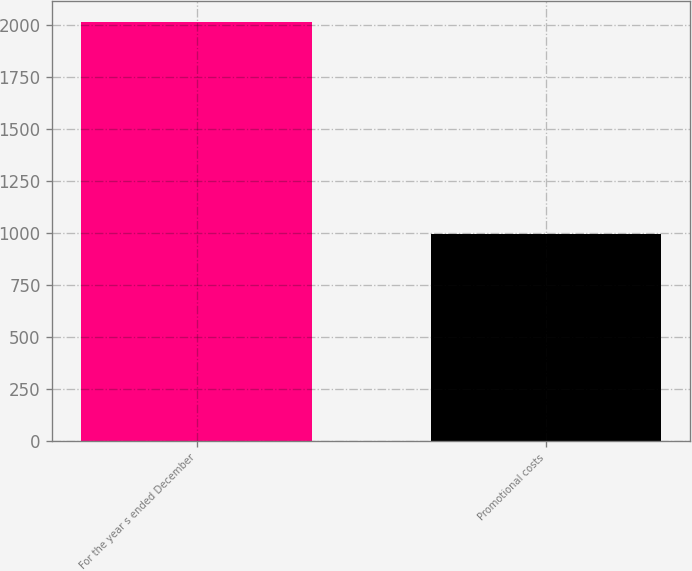<chart> <loc_0><loc_0><loc_500><loc_500><bar_chart><fcel>For the year s ended December<fcel>Promotional costs<nl><fcel>2013<fcel>995.7<nl></chart> 